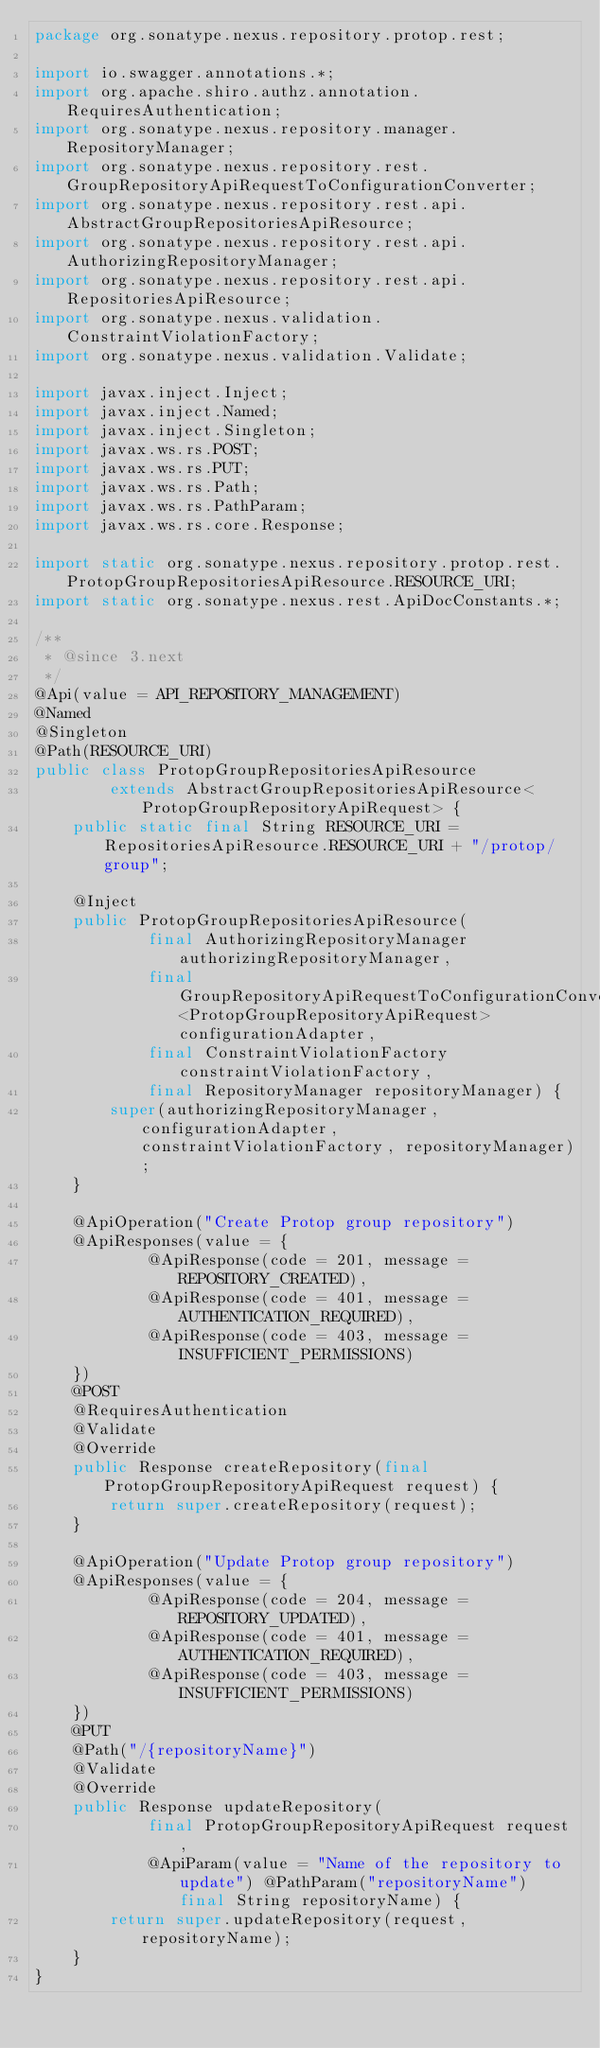<code> <loc_0><loc_0><loc_500><loc_500><_Java_>package org.sonatype.nexus.repository.protop.rest;

import io.swagger.annotations.*;
import org.apache.shiro.authz.annotation.RequiresAuthentication;
import org.sonatype.nexus.repository.manager.RepositoryManager;
import org.sonatype.nexus.repository.rest.GroupRepositoryApiRequestToConfigurationConverter;
import org.sonatype.nexus.repository.rest.api.AbstractGroupRepositoriesApiResource;
import org.sonatype.nexus.repository.rest.api.AuthorizingRepositoryManager;
import org.sonatype.nexus.repository.rest.api.RepositoriesApiResource;
import org.sonatype.nexus.validation.ConstraintViolationFactory;
import org.sonatype.nexus.validation.Validate;

import javax.inject.Inject;
import javax.inject.Named;
import javax.inject.Singleton;
import javax.ws.rs.POST;
import javax.ws.rs.PUT;
import javax.ws.rs.Path;
import javax.ws.rs.PathParam;
import javax.ws.rs.core.Response;

import static org.sonatype.nexus.repository.protop.rest.ProtopGroupRepositoriesApiResource.RESOURCE_URI;
import static org.sonatype.nexus.rest.ApiDocConstants.*;

/**
 * @since 3.next
 */
@Api(value = API_REPOSITORY_MANAGEMENT)
@Named
@Singleton
@Path(RESOURCE_URI)
public class ProtopGroupRepositoriesApiResource
        extends AbstractGroupRepositoriesApiResource<ProtopGroupRepositoryApiRequest> {
    public static final String RESOURCE_URI = RepositoriesApiResource.RESOURCE_URI + "/protop/group";

    @Inject
    public ProtopGroupRepositoriesApiResource(
            final AuthorizingRepositoryManager authorizingRepositoryManager,
            final GroupRepositoryApiRequestToConfigurationConverter<ProtopGroupRepositoryApiRequest> configurationAdapter,
            final ConstraintViolationFactory constraintViolationFactory,
            final RepositoryManager repositoryManager) {
        super(authorizingRepositoryManager, configurationAdapter, constraintViolationFactory, repositoryManager);
    }

    @ApiOperation("Create Protop group repository")
    @ApiResponses(value = {
            @ApiResponse(code = 201, message = REPOSITORY_CREATED),
            @ApiResponse(code = 401, message = AUTHENTICATION_REQUIRED),
            @ApiResponse(code = 403, message = INSUFFICIENT_PERMISSIONS)
    })
    @POST
    @RequiresAuthentication
    @Validate
    @Override
    public Response createRepository(final ProtopGroupRepositoryApiRequest request) {
        return super.createRepository(request);
    }

    @ApiOperation("Update Protop group repository")
    @ApiResponses(value = {
            @ApiResponse(code = 204, message = REPOSITORY_UPDATED),
            @ApiResponse(code = 401, message = AUTHENTICATION_REQUIRED),
            @ApiResponse(code = 403, message = INSUFFICIENT_PERMISSIONS)
    })
    @PUT
    @Path("/{repositoryName}")
    @Validate
    @Override
    public Response updateRepository(
            final ProtopGroupRepositoryApiRequest request,
            @ApiParam(value = "Name of the repository to update") @PathParam("repositoryName") final String repositoryName) {
        return super.updateRepository(request, repositoryName);
    }
}
</code> 